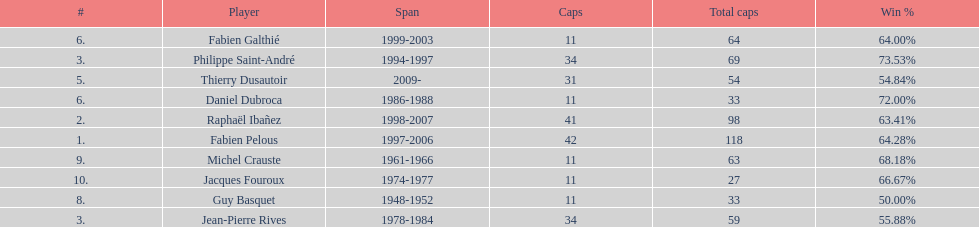How many caps did guy basquet accrue during his career? 33. 